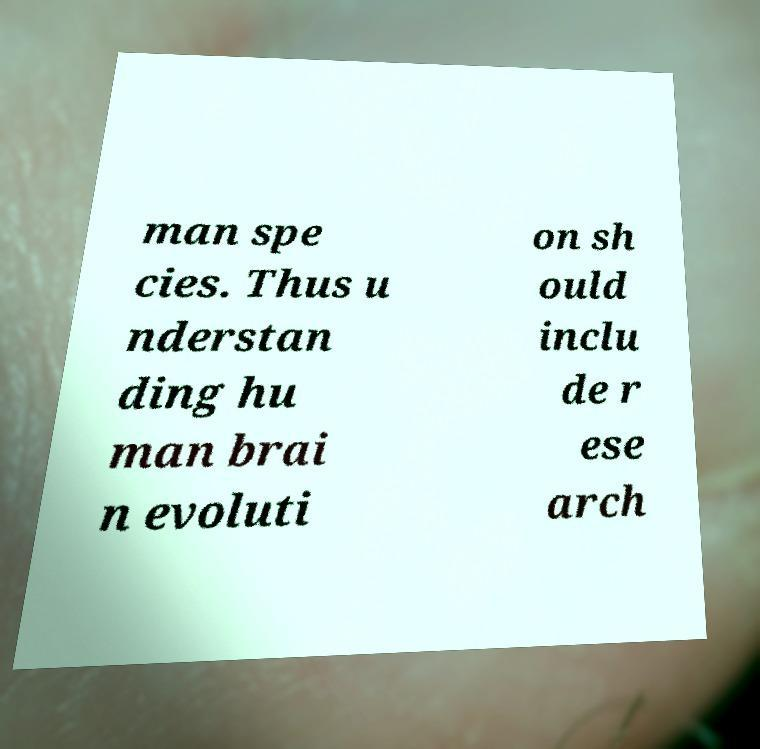What messages or text are displayed in this image? I need them in a readable, typed format. man spe cies. Thus u nderstan ding hu man brai n evoluti on sh ould inclu de r ese arch 